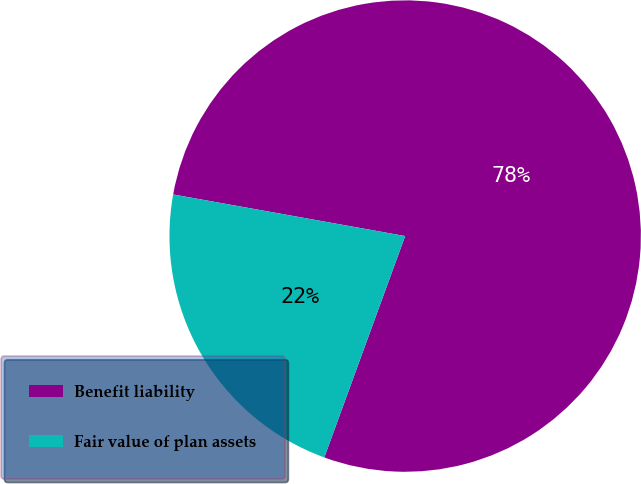Convert chart to OTSL. <chart><loc_0><loc_0><loc_500><loc_500><pie_chart><fcel>Benefit liability<fcel>Fair value of plan assets<nl><fcel>77.75%<fcel>22.25%<nl></chart> 